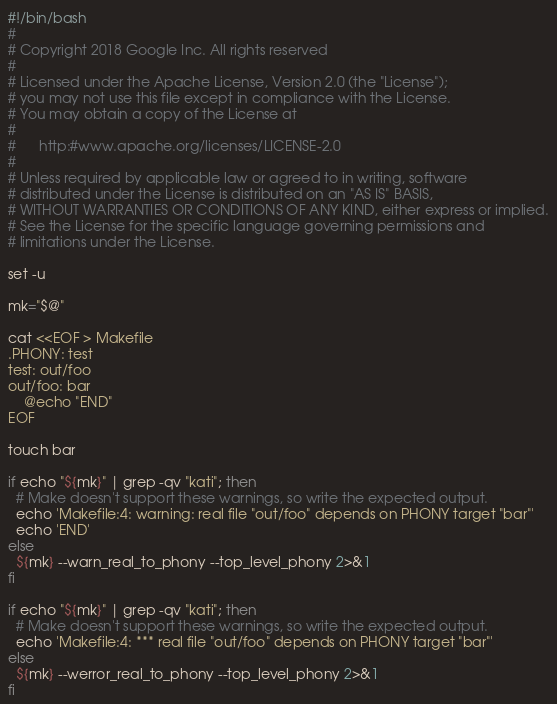Convert code to text. <code><loc_0><loc_0><loc_500><loc_500><_Bash_>#!/bin/bash
#
# Copyright 2018 Google Inc. All rights reserved
#
# Licensed under the Apache License, Version 2.0 (the "License");
# you may not use this file except in compliance with the License.
# You may obtain a copy of the License at
#
#      http:#www.apache.org/licenses/LICENSE-2.0
#
# Unless required by applicable law or agreed to in writing, software
# distributed under the License is distributed on an "AS IS" BASIS,
# WITHOUT WARRANTIES OR CONDITIONS OF ANY KIND, either express or implied.
# See the License for the specific language governing permissions and
# limitations under the License.

set -u

mk="$@"

cat <<EOF > Makefile
.PHONY: test
test: out/foo
out/foo: bar
	@echo "END"
EOF

touch bar

if echo "${mk}" | grep -qv "kati"; then
  # Make doesn't support these warnings, so write the expected output.
  echo 'Makefile:4: warning: real file "out/foo" depends on PHONY target "bar"'
  echo 'END'
else
  ${mk} --warn_real_to_phony --top_level_phony 2>&1
fi

if echo "${mk}" | grep -qv "kati"; then
  # Make doesn't support these warnings, so write the expected output.
  echo 'Makefile:4: *** real file "out/foo" depends on PHONY target "bar"'
else
  ${mk} --werror_real_to_phony --top_level_phony 2>&1
fi
</code> 